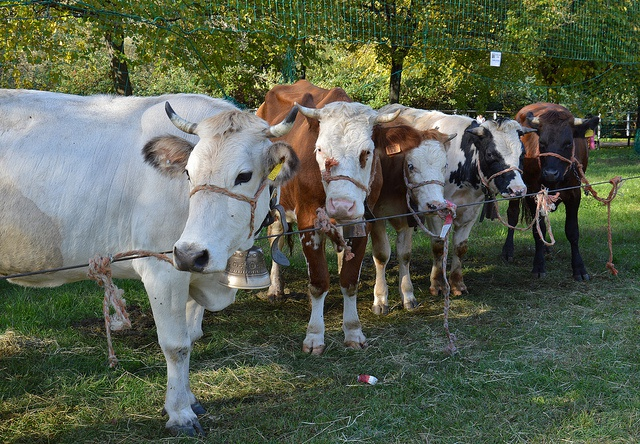Describe the objects in this image and their specific colors. I can see cow in teal, darkgray, gray, and lightgray tones, cow in teal, black, maroon, darkgray, and gray tones, cow in teal, black, gray, darkgray, and lightgray tones, cow in teal, black, gray, darkgray, and maroon tones, and cow in teal, black, gray, maroon, and brown tones in this image. 